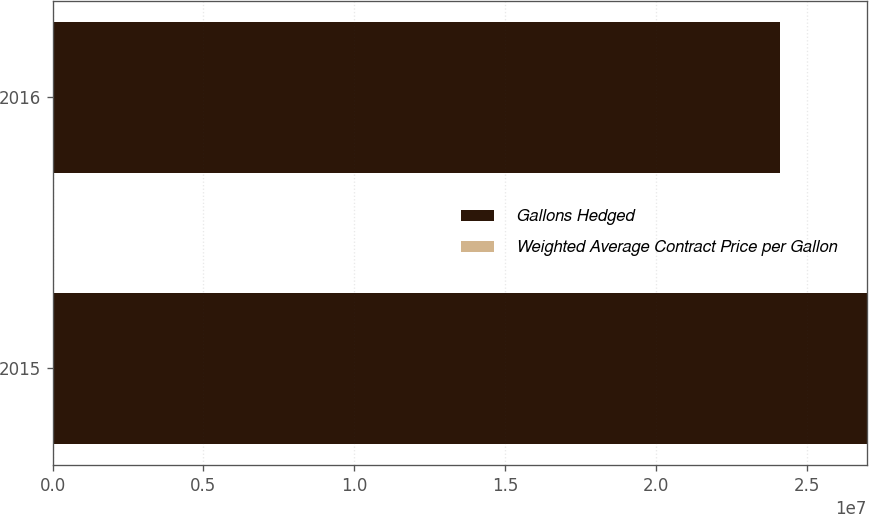Convert chart to OTSL. <chart><loc_0><loc_0><loc_500><loc_500><stacked_bar_chart><ecel><fcel>2015<fcel>2016<nl><fcel>Gallons Hedged<fcel>2.7e+07<fcel>2.412e+07<nl><fcel>Weighted Average Contract Price per Gallon<fcel>3.76<fcel>3.64<nl></chart> 